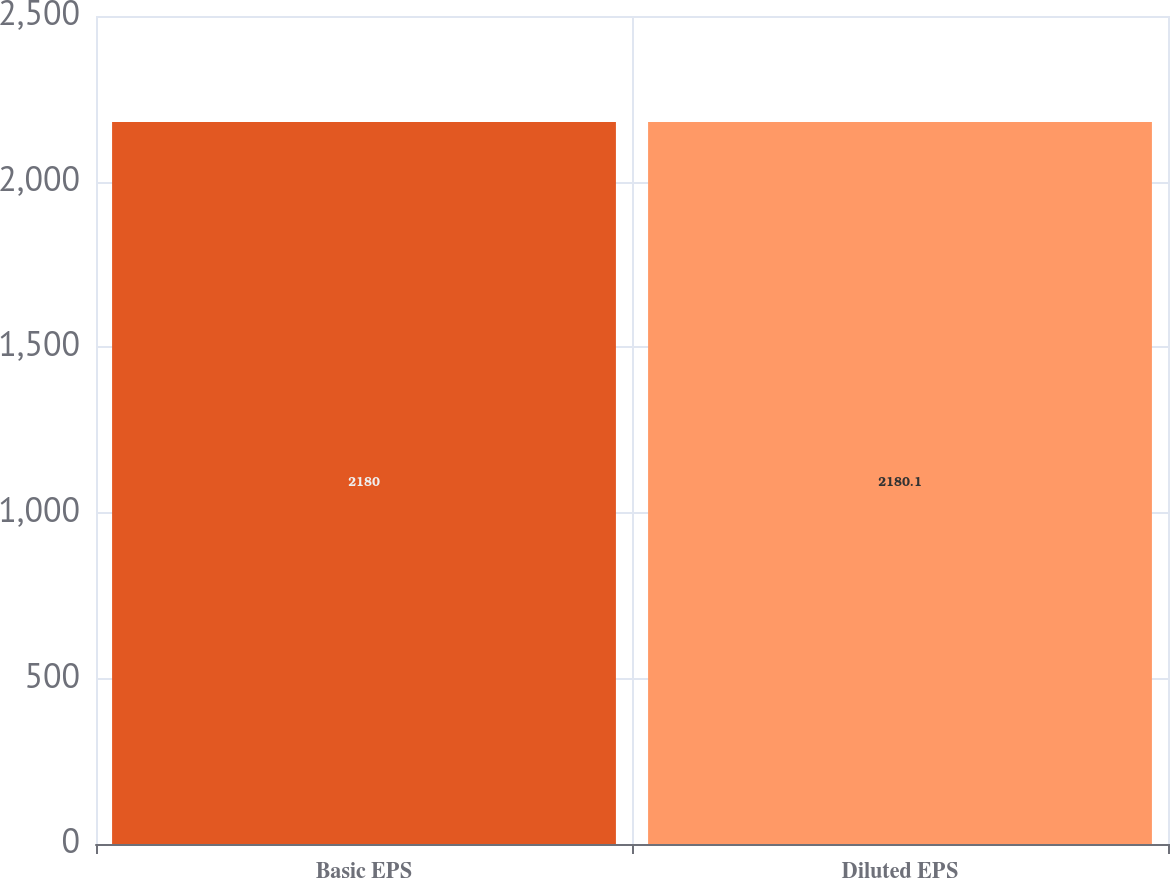Convert chart to OTSL. <chart><loc_0><loc_0><loc_500><loc_500><bar_chart><fcel>Basic EPS<fcel>Diluted EPS<nl><fcel>2180<fcel>2180.1<nl></chart> 